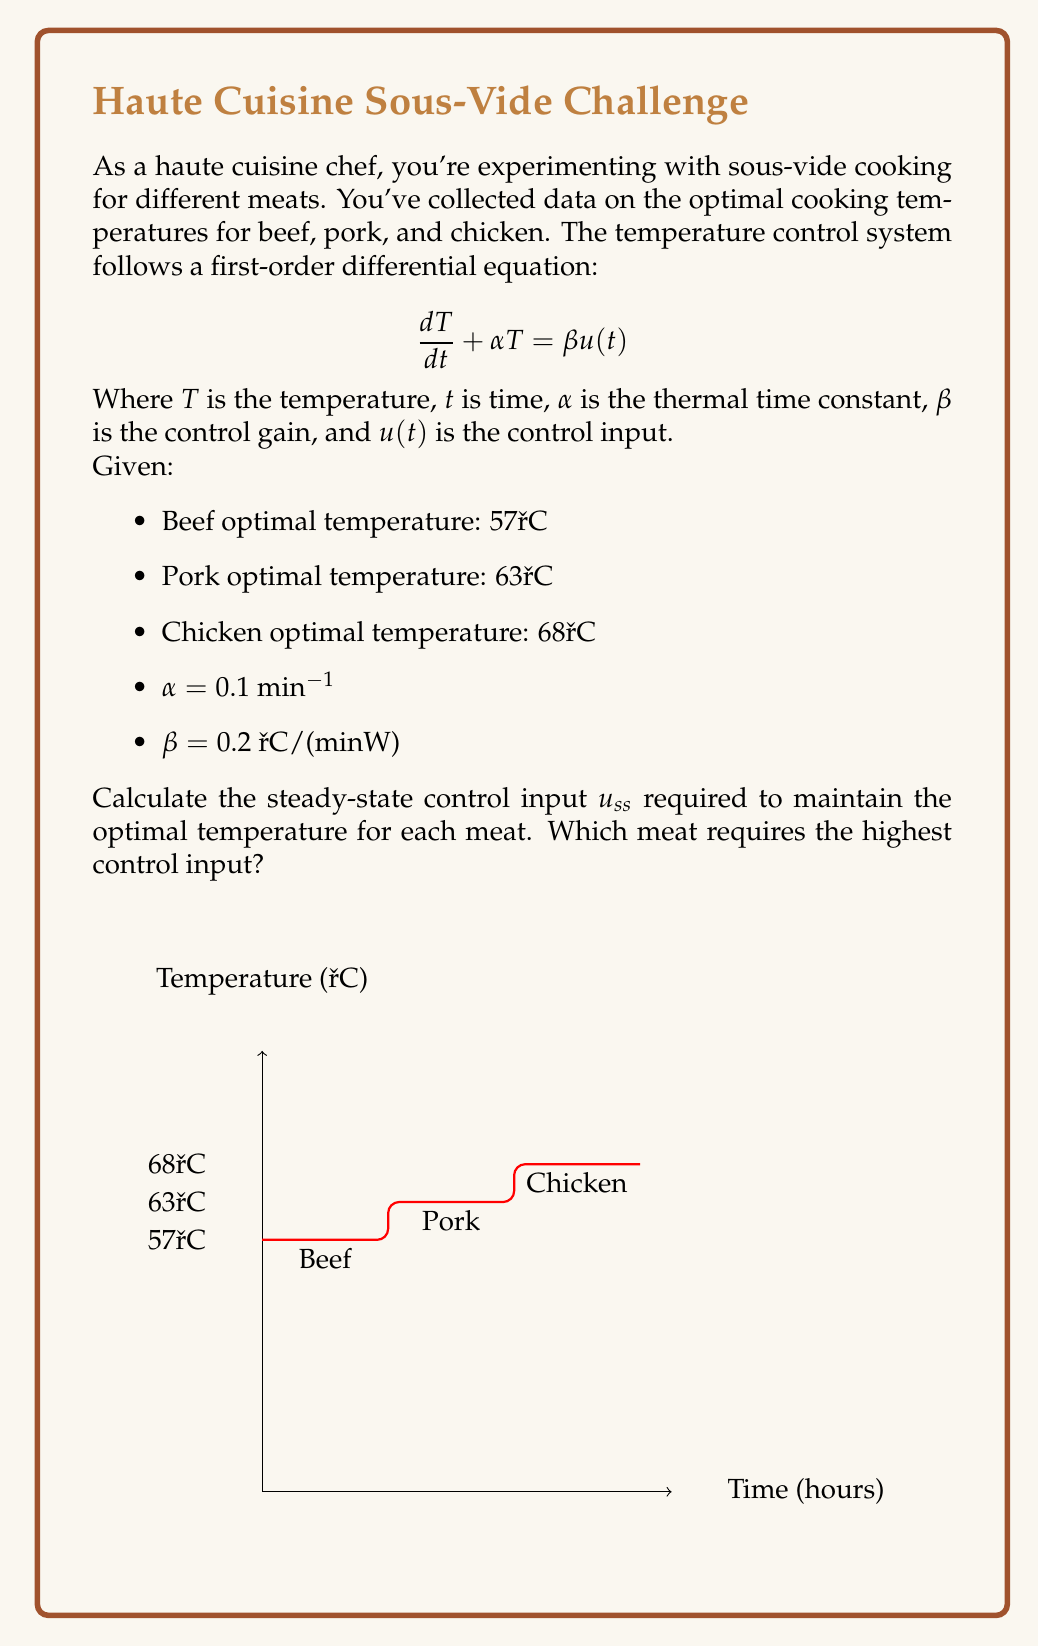Could you help me with this problem? To solve this problem, we'll follow these steps:

1) In steady-state, the temperature doesn't change with time, so $\frac{dT}{dt} = 0$. 

2) The steady-state equation becomes:

   $$\alpha T_{ss} = \beta u_{ss}$$

3) Rearranging to solve for $u_{ss}$:

   $$u_{ss} = \frac{\alpha T_{ss}}{\beta}$$

4) Now, let's calculate $u_{ss}$ for each meat:

   For Beef (57°C):
   $$u_{ss,beef} = \frac{0.1 \cdot 57}{0.2} = 28.5 \text{ W}$$

   For Pork (63°C):
   $$u_{ss,pork} = \frac{0.1 \cdot 63}{0.2} = 31.5 \text{ W}$$

   For Chicken (68°C):
   $$u_{ss,chicken} = \frac{0.1 \cdot 68}{0.2} = 34 \text{ W}$$

5) Comparing the results, we see that chicken requires the highest control input.

This aligns with culinary experience, as chicken generally needs to be cooked to a higher temperature than beef or pork for food safety reasons.
Answer: Beef: 28.5 W, Pork: 31.5 W, Chicken: 34 W. Chicken requires the highest input. 